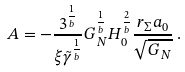Convert formula to latex. <formula><loc_0><loc_0><loc_500><loc_500>A = - \frac { 3 ^ { \frac { 1 } { b } } } { \xi \tilde { \gamma } ^ { \frac { 1 } { b } } } G _ { \, N } ^ { \frac { 1 } { b } } H _ { 0 } ^ { \frac { 2 } { b } } \frac { r _ { \Sigma } a _ { 0 } } { \sqrt { G _ { \, N } } } \, .</formula> 